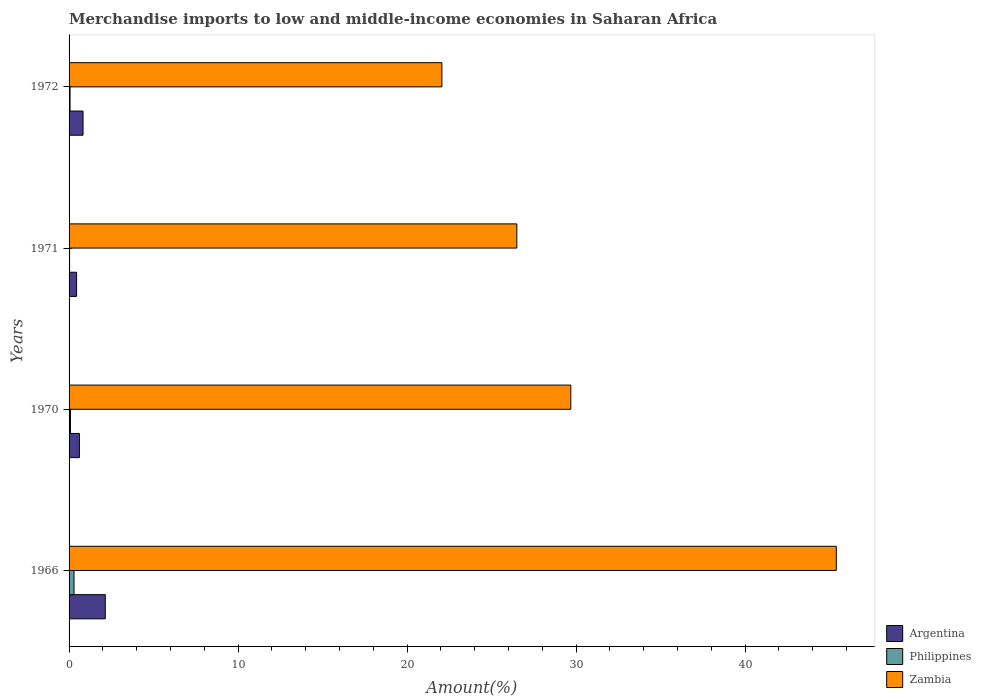How many different coloured bars are there?
Your response must be concise. 3. Are the number of bars on each tick of the Y-axis equal?
Make the answer very short. Yes. How many bars are there on the 2nd tick from the top?
Offer a very short reply. 3. How many bars are there on the 4th tick from the bottom?
Give a very brief answer. 3. What is the percentage of amount earned from merchandise imports in Argentina in 1972?
Ensure brevity in your answer.  0.83. Across all years, what is the maximum percentage of amount earned from merchandise imports in Argentina?
Make the answer very short. 2.14. Across all years, what is the minimum percentage of amount earned from merchandise imports in Argentina?
Provide a succinct answer. 0.45. In which year was the percentage of amount earned from merchandise imports in Philippines maximum?
Provide a succinct answer. 1966. What is the total percentage of amount earned from merchandise imports in Zambia in the graph?
Provide a short and direct response. 123.66. What is the difference between the percentage of amount earned from merchandise imports in Philippines in 1966 and that in 1970?
Make the answer very short. 0.21. What is the difference between the percentage of amount earned from merchandise imports in Zambia in 1966 and the percentage of amount earned from merchandise imports in Philippines in 1971?
Provide a short and direct response. 45.37. What is the average percentage of amount earned from merchandise imports in Argentina per year?
Your response must be concise. 1.01. In the year 1971, what is the difference between the percentage of amount earned from merchandise imports in Zambia and percentage of amount earned from merchandise imports in Philippines?
Your answer should be very brief. 26.47. What is the ratio of the percentage of amount earned from merchandise imports in Argentina in 1970 to that in 1972?
Give a very brief answer. 0.74. Is the difference between the percentage of amount earned from merchandise imports in Zambia in 1970 and 1972 greater than the difference between the percentage of amount earned from merchandise imports in Philippines in 1970 and 1972?
Offer a very short reply. Yes. What is the difference between the highest and the second highest percentage of amount earned from merchandise imports in Argentina?
Your response must be concise. 1.32. What is the difference between the highest and the lowest percentage of amount earned from merchandise imports in Zambia?
Ensure brevity in your answer.  23.34. Is the sum of the percentage of amount earned from merchandise imports in Philippines in 1966 and 1971 greater than the maximum percentage of amount earned from merchandise imports in Argentina across all years?
Offer a very short reply. No. What does the 3rd bar from the top in 1966 represents?
Offer a very short reply. Argentina. What does the 3rd bar from the bottom in 1972 represents?
Provide a short and direct response. Zambia. How many bars are there?
Give a very brief answer. 12. Are all the bars in the graph horizontal?
Ensure brevity in your answer.  Yes. How many years are there in the graph?
Make the answer very short. 4. What is the difference between two consecutive major ticks on the X-axis?
Offer a very short reply. 10. Does the graph contain any zero values?
Your answer should be compact. No. Does the graph contain grids?
Make the answer very short. No. What is the title of the graph?
Your response must be concise. Merchandise imports to low and middle-income economies in Saharan Africa. Does "Gambia, The" appear as one of the legend labels in the graph?
Your answer should be very brief. No. What is the label or title of the X-axis?
Ensure brevity in your answer.  Amount(%). What is the label or title of the Y-axis?
Offer a terse response. Years. What is the Amount(%) in Argentina in 1966?
Make the answer very short. 2.14. What is the Amount(%) in Philippines in 1966?
Give a very brief answer. 0.29. What is the Amount(%) of Zambia in 1966?
Give a very brief answer. 45.4. What is the Amount(%) of Argentina in 1970?
Keep it short and to the point. 0.61. What is the Amount(%) of Philippines in 1970?
Provide a succinct answer. 0.08. What is the Amount(%) in Zambia in 1970?
Ensure brevity in your answer.  29.69. What is the Amount(%) in Argentina in 1971?
Make the answer very short. 0.45. What is the Amount(%) of Philippines in 1971?
Provide a short and direct response. 0.03. What is the Amount(%) of Zambia in 1971?
Keep it short and to the point. 26.5. What is the Amount(%) of Argentina in 1972?
Your answer should be compact. 0.83. What is the Amount(%) of Philippines in 1972?
Keep it short and to the point. 0.06. What is the Amount(%) in Zambia in 1972?
Make the answer very short. 22.06. Across all years, what is the maximum Amount(%) in Argentina?
Your answer should be very brief. 2.14. Across all years, what is the maximum Amount(%) in Philippines?
Offer a very short reply. 0.29. Across all years, what is the maximum Amount(%) of Zambia?
Your answer should be compact. 45.4. Across all years, what is the minimum Amount(%) of Argentina?
Keep it short and to the point. 0.45. Across all years, what is the minimum Amount(%) in Philippines?
Make the answer very short. 0.03. Across all years, what is the minimum Amount(%) in Zambia?
Keep it short and to the point. 22.06. What is the total Amount(%) of Argentina in the graph?
Offer a terse response. 4.03. What is the total Amount(%) of Philippines in the graph?
Keep it short and to the point. 0.46. What is the total Amount(%) of Zambia in the graph?
Make the answer very short. 123.66. What is the difference between the Amount(%) in Argentina in 1966 and that in 1970?
Provide a short and direct response. 1.53. What is the difference between the Amount(%) in Philippines in 1966 and that in 1970?
Your response must be concise. 0.21. What is the difference between the Amount(%) of Zambia in 1966 and that in 1970?
Give a very brief answer. 15.71. What is the difference between the Amount(%) of Argentina in 1966 and that in 1971?
Offer a terse response. 1.7. What is the difference between the Amount(%) of Philippines in 1966 and that in 1971?
Give a very brief answer. 0.26. What is the difference between the Amount(%) of Zambia in 1966 and that in 1971?
Make the answer very short. 18.91. What is the difference between the Amount(%) of Argentina in 1966 and that in 1972?
Ensure brevity in your answer.  1.32. What is the difference between the Amount(%) in Philippines in 1966 and that in 1972?
Give a very brief answer. 0.23. What is the difference between the Amount(%) in Zambia in 1966 and that in 1972?
Ensure brevity in your answer.  23.34. What is the difference between the Amount(%) in Argentina in 1970 and that in 1971?
Your answer should be compact. 0.16. What is the difference between the Amount(%) in Philippines in 1970 and that in 1971?
Your answer should be very brief. 0.05. What is the difference between the Amount(%) in Zambia in 1970 and that in 1971?
Provide a short and direct response. 3.2. What is the difference between the Amount(%) in Argentina in 1970 and that in 1972?
Give a very brief answer. -0.22. What is the difference between the Amount(%) in Philippines in 1970 and that in 1972?
Offer a terse response. 0.02. What is the difference between the Amount(%) in Zambia in 1970 and that in 1972?
Your answer should be very brief. 7.63. What is the difference between the Amount(%) of Argentina in 1971 and that in 1972?
Your answer should be very brief. -0.38. What is the difference between the Amount(%) of Philippines in 1971 and that in 1972?
Your answer should be very brief. -0.03. What is the difference between the Amount(%) in Zambia in 1971 and that in 1972?
Provide a short and direct response. 4.43. What is the difference between the Amount(%) of Argentina in 1966 and the Amount(%) of Philippines in 1970?
Your answer should be compact. 2.06. What is the difference between the Amount(%) in Argentina in 1966 and the Amount(%) in Zambia in 1970?
Provide a succinct answer. -27.55. What is the difference between the Amount(%) of Philippines in 1966 and the Amount(%) of Zambia in 1970?
Keep it short and to the point. -29.4. What is the difference between the Amount(%) in Argentina in 1966 and the Amount(%) in Philippines in 1971?
Provide a short and direct response. 2.11. What is the difference between the Amount(%) of Argentina in 1966 and the Amount(%) of Zambia in 1971?
Provide a short and direct response. -24.35. What is the difference between the Amount(%) in Philippines in 1966 and the Amount(%) in Zambia in 1971?
Provide a short and direct response. -26.2. What is the difference between the Amount(%) in Argentina in 1966 and the Amount(%) in Philippines in 1972?
Provide a succinct answer. 2.08. What is the difference between the Amount(%) in Argentina in 1966 and the Amount(%) in Zambia in 1972?
Make the answer very short. -19.92. What is the difference between the Amount(%) of Philippines in 1966 and the Amount(%) of Zambia in 1972?
Make the answer very short. -21.77. What is the difference between the Amount(%) of Argentina in 1970 and the Amount(%) of Philippines in 1971?
Your answer should be compact. 0.58. What is the difference between the Amount(%) of Argentina in 1970 and the Amount(%) of Zambia in 1971?
Keep it short and to the point. -25.89. What is the difference between the Amount(%) of Philippines in 1970 and the Amount(%) of Zambia in 1971?
Provide a short and direct response. -26.41. What is the difference between the Amount(%) in Argentina in 1970 and the Amount(%) in Philippines in 1972?
Your answer should be compact. 0.55. What is the difference between the Amount(%) of Argentina in 1970 and the Amount(%) of Zambia in 1972?
Offer a terse response. -21.45. What is the difference between the Amount(%) in Philippines in 1970 and the Amount(%) in Zambia in 1972?
Provide a short and direct response. -21.98. What is the difference between the Amount(%) of Argentina in 1971 and the Amount(%) of Philippines in 1972?
Offer a very short reply. 0.39. What is the difference between the Amount(%) in Argentina in 1971 and the Amount(%) in Zambia in 1972?
Your response must be concise. -21.62. What is the difference between the Amount(%) of Philippines in 1971 and the Amount(%) of Zambia in 1972?
Keep it short and to the point. -22.03. What is the average Amount(%) in Philippines per year?
Keep it short and to the point. 0.12. What is the average Amount(%) of Zambia per year?
Your answer should be compact. 30.91. In the year 1966, what is the difference between the Amount(%) in Argentina and Amount(%) in Philippines?
Give a very brief answer. 1.85. In the year 1966, what is the difference between the Amount(%) of Argentina and Amount(%) of Zambia?
Your response must be concise. -43.26. In the year 1966, what is the difference between the Amount(%) of Philippines and Amount(%) of Zambia?
Offer a very short reply. -45.11. In the year 1970, what is the difference between the Amount(%) of Argentina and Amount(%) of Philippines?
Provide a succinct answer. 0.53. In the year 1970, what is the difference between the Amount(%) in Argentina and Amount(%) in Zambia?
Your answer should be compact. -29.08. In the year 1970, what is the difference between the Amount(%) in Philippines and Amount(%) in Zambia?
Provide a short and direct response. -29.61. In the year 1971, what is the difference between the Amount(%) of Argentina and Amount(%) of Philippines?
Provide a succinct answer. 0.42. In the year 1971, what is the difference between the Amount(%) in Argentina and Amount(%) in Zambia?
Your answer should be compact. -26.05. In the year 1971, what is the difference between the Amount(%) in Philippines and Amount(%) in Zambia?
Your answer should be very brief. -26.47. In the year 1972, what is the difference between the Amount(%) in Argentina and Amount(%) in Philippines?
Make the answer very short. 0.77. In the year 1972, what is the difference between the Amount(%) of Argentina and Amount(%) of Zambia?
Provide a short and direct response. -21.24. In the year 1972, what is the difference between the Amount(%) of Philippines and Amount(%) of Zambia?
Keep it short and to the point. -22. What is the ratio of the Amount(%) of Argentina in 1966 to that in 1970?
Your answer should be compact. 3.51. What is the ratio of the Amount(%) in Philippines in 1966 to that in 1970?
Your answer should be very brief. 3.53. What is the ratio of the Amount(%) in Zambia in 1966 to that in 1970?
Your response must be concise. 1.53. What is the ratio of the Amount(%) in Argentina in 1966 to that in 1971?
Your answer should be compact. 4.8. What is the ratio of the Amount(%) in Philippines in 1966 to that in 1971?
Offer a very short reply. 9.72. What is the ratio of the Amount(%) of Zambia in 1966 to that in 1971?
Offer a very short reply. 1.71. What is the ratio of the Amount(%) of Argentina in 1966 to that in 1972?
Your answer should be very brief. 2.59. What is the ratio of the Amount(%) in Philippines in 1966 to that in 1972?
Provide a short and direct response. 4.99. What is the ratio of the Amount(%) in Zambia in 1966 to that in 1972?
Give a very brief answer. 2.06. What is the ratio of the Amount(%) in Argentina in 1970 to that in 1971?
Your answer should be very brief. 1.37. What is the ratio of the Amount(%) of Philippines in 1970 to that in 1971?
Keep it short and to the point. 2.76. What is the ratio of the Amount(%) of Zambia in 1970 to that in 1971?
Offer a very short reply. 1.12. What is the ratio of the Amount(%) in Argentina in 1970 to that in 1972?
Make the answer very short. 0.74. What is the ratio of the Amount(%) of Philippines in 1970 to that in 1972?
Keep it short and to the point. 1.42. What is the ratio of the Amount(%) in Zambia in 1970 to that in 1972?
Give a very brief answer. 1.35. What is the ratio of the Amount(%) of Argentina in 1971 to that in 1972?
Provide a succinct answer. 0.54. What is the ratio of the Amount(%) in Philippines in 1971 to that in 1972?
Provide a short and direct response. 0.51. What is the ratio of the Amount(%) in Zambia in 1971 to that in 1972?
Provide a short and direct response. 1.2. What is the difference between the highest and the second highest Amount(%) in Argentina?
Your answer should be very brief. 1.32. What is the difference between the highest and the second highest Amount(%) of Philippines?
Your response must be concise. 0.21. What is the difference between the highest and the second highest Amount(%) of Zambia?
Provide a succinct answer. 15.71. What is the difference between the highest and the lowest Amount(%) in Argentina?
Give a very brief answer. 1.7. What is the difference between the highest and the lowest Amount(%) of Philippines?
Your response must be concise. 0.26. What is the difference between the highest and the lowest Amount(%) of Zambia?
Offer a very short reply. 23.34. 